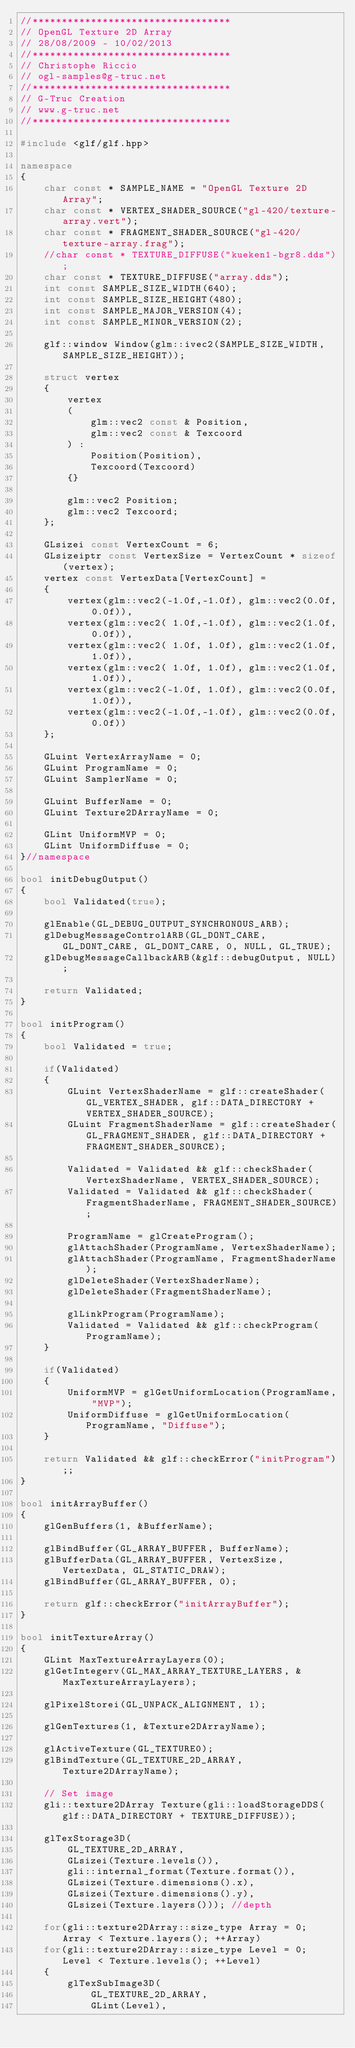<code> <loc_0><loc_0><loc_500><loc_500><_C++_>//**********************************
// OpenGL Texture 2D Array
// 28/08/2009 - 10/02/2013
//**********************************
// Christophe Riccio
// ogl-samples@g-truc.net
//**********************************
// G-Truc Creation
// www.g-truc.net
//**********************************

#include <glf/glf.hpp>

namespace
{
	char const * SAMPLE_NAME = "OpenGL Texture 2D Array";
	char const * VERTEX_SHADER_SOURCE("gl-420/texture-array.vert");
	char const * FRAGMENT_SHADER_SOURCE("gl-420/texture-array.frag");
	//char const * TEXTURE_DIFFUSE("kueken1-bgr8.dds");
	char const * TEXTURE_DIFFUSE("array.dds");
	int const SAMPLE_SIZE_WIDTH(640);
	int const SAMPLE_SIZE_HEIGHT(480);
	int const SAMPLE_MAJOR_VERSION(4);
	int const SAMPLE_MINOR_VERSION(2);

	glf::window Window(glm::ivec2(SAMPLE_SIZE_WIDTH, SAMPLE_SIZE_HEIGHT));

	struct vertex
	{
		vertex
		(
			glm::vec2 const & Position,
			glm::vec2 const & Texcoord
		) :
			Position(Position),
			Texcoord(Texcoord)
		{}

		glm::vec2 Position;
		glm::vec2 Texcoord;
	};

	GLsizei const VertexCount = 6;
	GLsizeiptr const VertexSize = VertexCount * sizeof(vertex);
	vertex const VertexData[VertexCount] =
	{
		vertex(glm::vec2(-1.0f,-1.0f), glm::vec2(0.0f, 0.0f)),
		vertex(glm::vec2( 1.0f,-1.0f), glm::vec2(1.0f, 0.0f)),
		vertex(glm::vec2( 1.0f, 1.0f), glm::vec2(1.0f, 1.0f)),
		vertex(glm::vec2( 1.0f, 1.0f), glm::vec2(1.0f, 1.0f)),
		vertex(glm::vec2(-1.0f, 1.0f), glm::vec2(0.0f, 1.0f)),
		vertex(glm::vec2(-1.0f,-1.0f), glm::vec2(0.0f, 0.0f))
	};

	GLuint VertexArrayName = 0;
	GLuint ProgramName = 0;
	GLuint SamplerName = 0;

	GLuint BufferName = 0;
	GLuint Texture2DArrayName = 0;

	GLint UniformMVP = 0;
	GLint UniformDiffuse = 0;
}//namespace

bool initDebugOutput()
{
	bool Validated(true);

	glEnable(GL_DEBUG_OUTPUT_SYNCHRONOUS_ARB);
	glDebugMessageControlARB(GL_DONT_CARE, GL_DONT_CARE, GL_DONT_CARE, 0, NULL, GL_TRUE);
	glDebugMessageCallbackARB(&glf::debugOutput, NULL);

	return Validated;
}

bool initProgram()
{
	bool Validated = true;
	
	if(Validated)
	{
		GLuint VertexShaderName = glf::createShader(GL_VERTEX_SHADER, glf::DATA_DIRECTORY + VERTEX_SHADER_SOURCE);
		GLuint FragmentShaderName = glf::createShader(GL_FRAGMENT_SHADER, glf::DATA_DIRECTORY + FRAGMENT_SHADER_SOURCE);

		Validated = Validated && glf::checkShader(VertexShaderName, VERTEX_SHADER_SOURCE);
		Validated = Validated && glf::checkShader(FragmentShaderName, FRAGMENT_SHADER_SOURCE);

		ProgramName = glCreateProgram();
		glAttachShader(ProgramName, VertexShaderName);
		glAttachShader(ProgramName, FragmentShaderName);
		glDeleteShader(VertexShaderName);
		glDeleteShader(FragmentShaderName);

		glLinkProgram(ProgramName);
		Validated = Validated && glf::checkProgram(ProgramName);
	}

	if(Validated)
	{
		UniformMVP = glGetUniformLocation(ProgramName, "MVP");
		UniformDiffuse = glGetUniformLocation(ProgramName, "Diffuse");
	}

	return Validated && glf::checkError("initProgram");;
}

bool initArrayBuffer()
{
	glGenBuffers(1, &BufferName);

	glBindBuffer(GL_ARRAY_BUFFER, BufferName);
	glBufferData(GL_ARRAY_BUFFER, VertexSize, VertexData, GL_STATIC_DRAW);
	glBindBuffer(GL_ARRAY_BUFFER, 0);

	return glf::checkError("initArrayBuffer");
}

bool initTextureArray()
{
	GLint MaxTextureArrayLayers(0);
	glGetIntegerv(GL_MAX_ARRAY_TEXTURE_LAYERS, &MaxTextureArrayLayers);

	glPixelStorei(GL_UNPACK_ALIGNMENT, 1);

	glGenTextures(1, &Texture2DArrayName);

	glActiveTexture(GL_TEXTURE0);
	glBindTexture(GL_TEXTURE_2D_ARRAY, Texture2DArrayName);

	// Set image
	gli::texture2DArray Texture(gli::loadStorageDDS(glf::DATA_DIRECTORY + TEXTURE_DIFFUSE));

	glTexStorage3D(
		GL_TEXTURE_2D_ARRAY,
		GLsizei(Texture.levels()),
		gli::internal_format(Texture.format()), 
		GLsizei(Texture.dimensions().x), 
		GLsizei(Texture.dimensions().y), 
		GLsizei(Texture.layers())); //depth

	for(gli::texture2DArray::size_type Array = 0; Array < Texture.layers(); ++Array)
	for(gli::texture2DArray::size_type Level = 0; Level < Texture.levels(); ++Level)
	{
		glTexSubImage3D(
			GL_TEXTURE_2D_ARRAY, 
			GLint(Level), </code> 